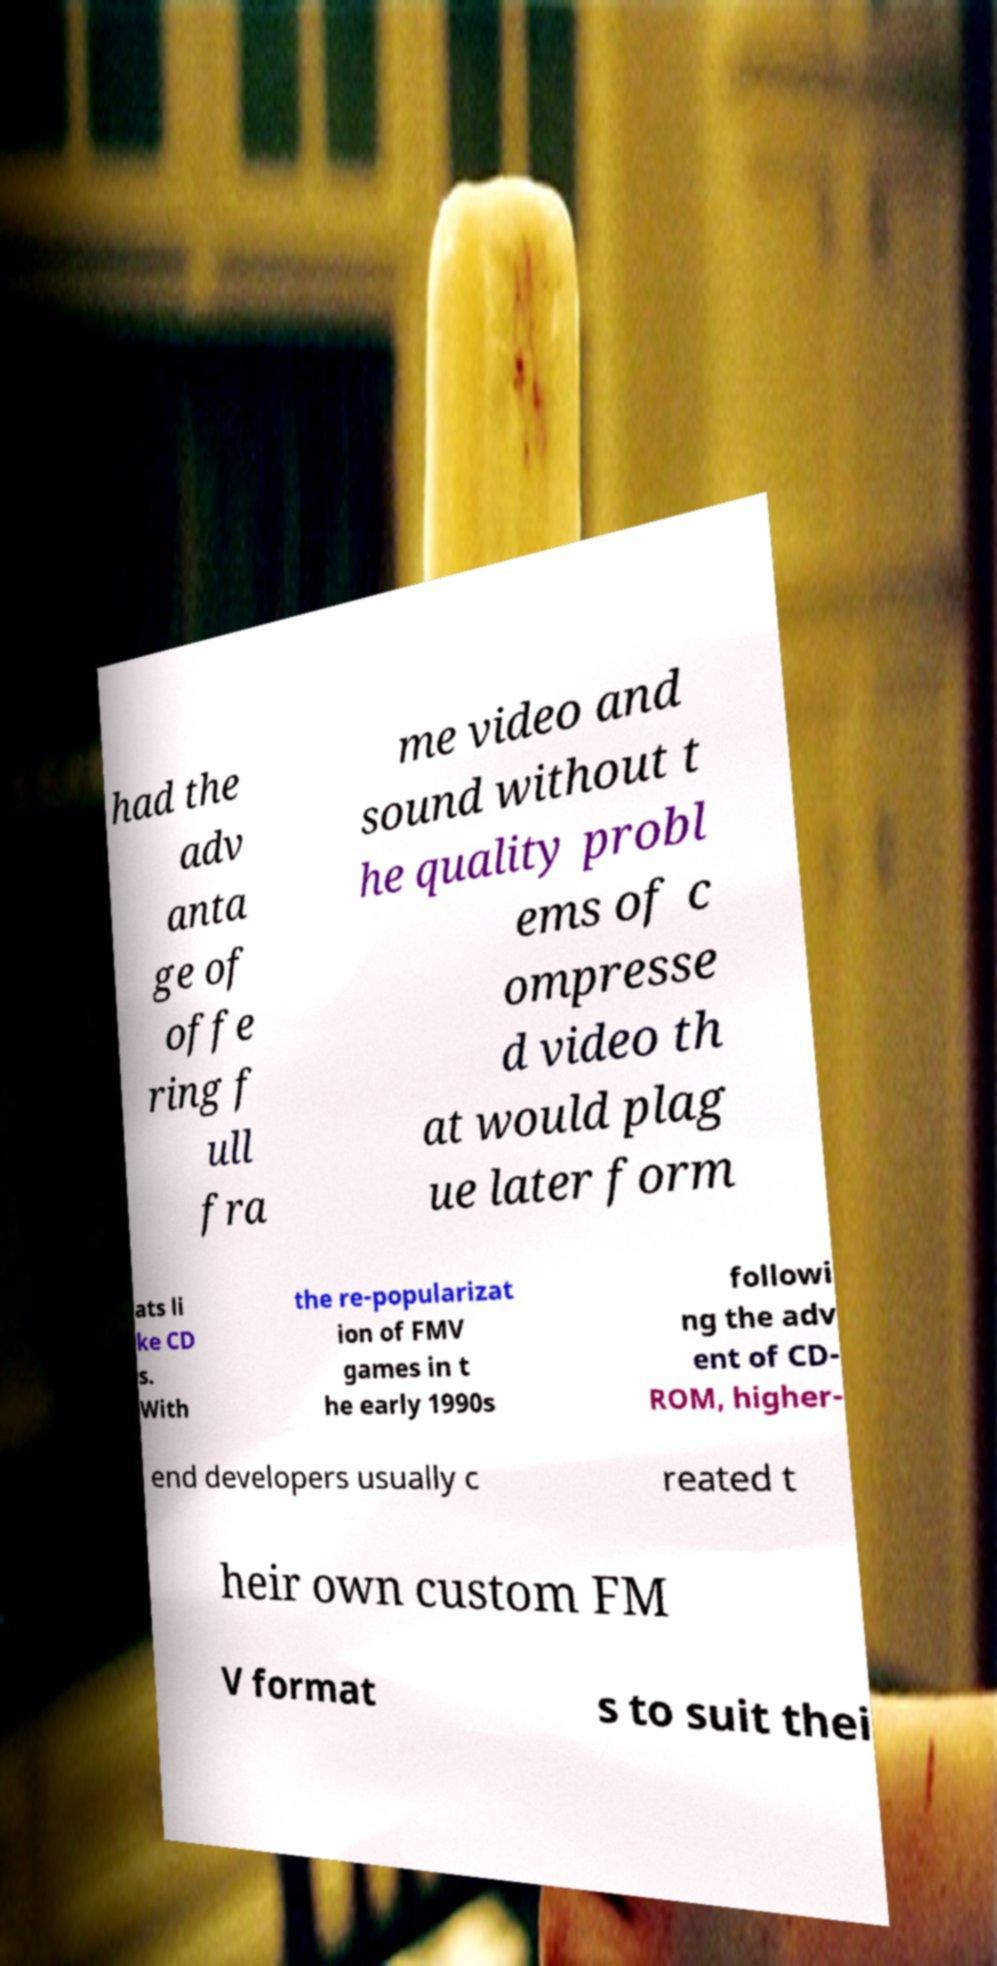Could you assist in decoding the text presented in this image and type it out clearly? had the adv anta ge of offe ring f ull fra me video and sound without t he quality probl ems of c ompresse d video th at would plag ue later form ats li ke CD s. With the re-popularizat ion of FMV games in t he early 1990s followi ng the adv ent of CD- ROM, higher- end developers usually c reated t heir own custom FM V format s to suit thei 